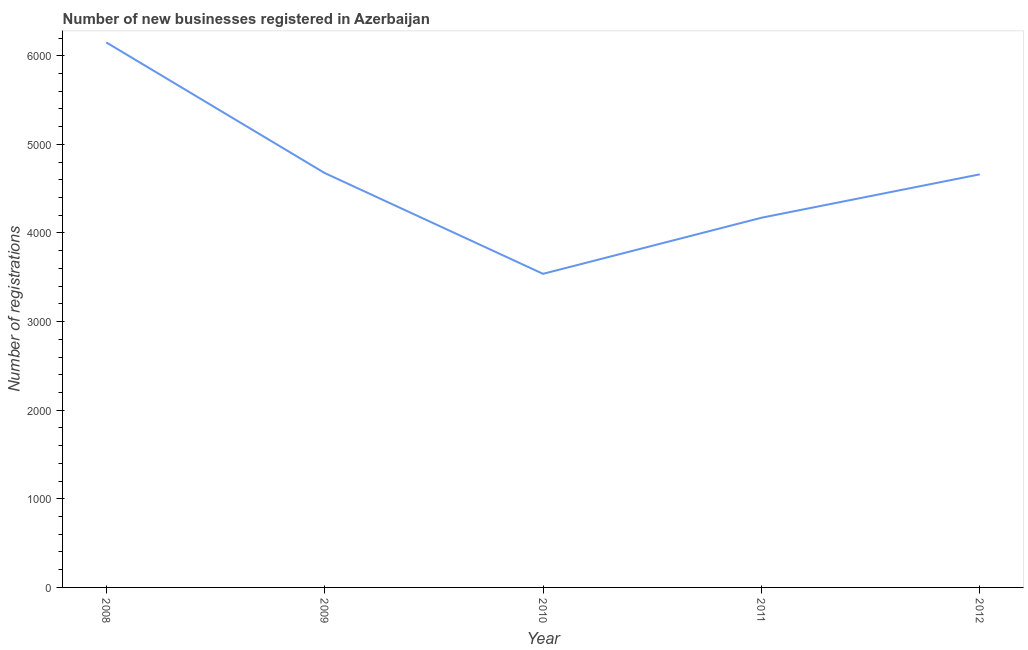What is the number of new business registrations in 2012?
Your response must be concise. 4662. Across all years, what is the maximum number of new business registrations?
Ensure brevity in your answer.  6151. Across all years, what is the minimum number of new business registrations?
Your response must be concise. 3539. In which year was the number of new business registrations minimum?
Your answer should be very brief. 2010. What is the sum of the number of new business registrations?
Your answer should be very brief. 2.32e+04. What is the difference between the number of new business registrations in 2010 and 2012?
Your answer should be compact. -1123. What is the average number of new business registrations per year?
Your answer should be very brief. 4640.2. What is the median number of new business registrations?
Your answer should be very brief. 4662. Do a majority of the years between 2010 and 2011 (inclusive) have number of new business registrations greater than 2000 ?
Your answer should be very brief. Yes. What is the ratio of the number of new business registrations in 2008 to that in 2012?
Offer a very short reply. 1.32. What is the difference between the highest and the second highest number of new business registrations?
Ensure brevity in your answer.  1474. Is the sum of the number of new business registrations in 2008 and 2009 greater than the maximum number of new business registrations across all years?
Give a very brief answer. Yes. What is the difference between the highest and the lowest number of new business registrations?
Your answer should be very brief. 2612. In how many years, is the number of new business registrations greater than the average number of new business registrations taken over all years?
Provide a short and direct response. 3. Does the number of new business registrations monotonically increase over the years?
Make the answer very short. No. How many lines are there?
Make the answer very short. 1. How many years are there in the graph?
Your response must be concise. 5. What is the difference between two consecutive major ticks on the Y-axis?
Your response must be concise. 1000. Does the graph contain any zero values?
Offer a very short reply. No. Does the graph contain grids?
Your answer should be very brief. No. What is the title of the graph?
Offer a very short reply. Number of new businesses registered in Azerbaijan. What is the label or title of the X-axis?
Your response must be concise. Year. What is the label or title of the Y-axis?
Your answer should be very brief. Number of registrations. What is the Number of registrations of 2008?
Your answer should be compact. 6151. What is the Number of registrations of 2009?
Offer a terse response. 4677. What is the Number of registrations in 2010?
Ensure brevity in your answer.  3539. What is the Number of registrations of 2011?
Make the answer very short. 4172. What is the Number of registrations of 2012?
Provide a short and direct response. 4662. What is the difference between the Number of registrations in 2008 and 2009?
Provide a short and direct response. 1474. What is the difference between the Number of registrations in 2008 and 2010?
Offer a very short reply. 2612. What is the difference between the Number of registrations in 2008 and 2011?
Make the answer very short. 1979. What is the difference between the Number of registrations in 2008 and 2012?
Your response must be concise. 1489. What is the difference between the Number of registrations in 2009 and 2010?
Make the answer very short. 1138. What is the difference between the Number of registrations in 2009 and 2011?
Make the answer very short. 505. What is the difference between the Number of registrations in 2010 and 2011?
Your answer should be very brief. -633. What is the difference between the Number of registrations in 2010 and 2012?
Offer a very short reply. -1123. What is the difference between the Number of registrations in 2011 and 2012?
Offer a terse response. -490. What is the ratio of the Number of registrations in 2008 to that in 2009?
Ensure brevity in your answer.  1.31. What is the ratio of the Number of registrations in 2008 to that in 2010?
Your answer should be compact. 1.74. What is the ratio of the Number of registrations in 2008 to that in 2011?
Your response must be concise. 1.47. What is the ratio of the Number of registrations in 2008 to that in 2012?
Ensure brevity in your answer.  1.32. What is the ratio of the Number of registrations in 2009 to that in 2010?
Provide a short and direct response. 1.32. What is the ratio of the Number of registrations in 2009 to that in 2011?
Give a very brief answer. 1.12. What is the ratio of the Number of registrations in 2009 to that in 2012?
Make the answer very short. 1. What is the ratio of the Number of registrations in 2010 to that in 2011?
Give a very brief answer. 0.85. What is the ratio of the Number of registrations in 2010 to that in 2012?
Your answer should be compact. 0.76. What is the ratio of the Number of registrations in 2011 to that in 2012?
Keep it short and to the point. 0.9. 